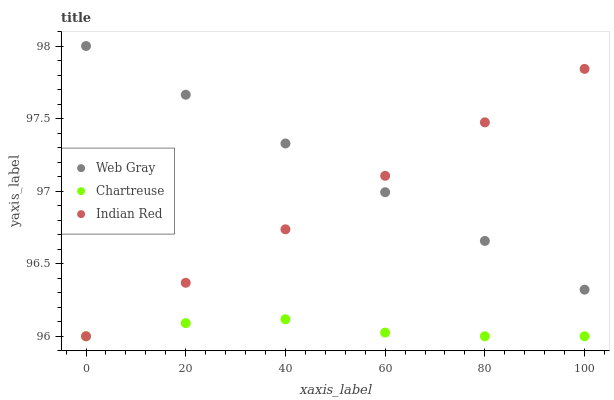Does Chartreuse have the minimum area under the curve?
Answer yes or no. Yes. Does Web Gray have the maximum area under the curve?
Answer yes or no. Yes. Does Indian Red have the minimum area under the curve?
Answer yes or no. No. Does Indian Red have the maximum area under the curve?
Answer yes or no. No. Is Web Gray the smoothest?
Answer yes or no. Yes. Is Chartreuse the roughest?
Answer yes or no. Yes. Is Indian Red the roughest?
Answer yes or no. No. Does Chartreuse have the lowest value?
Answer yes or no. Yes. Does Web Gray have the lowest value?
Answer yes or no. No. Does Web Gray have the highest value?
Answer yes or no. Yes. Does Indian Red have the highest value?
Answer yes or no. No. Is Chartreuse less than Web Gray?
Answer yes or no. Yes. Is Web Gray greater than Chartreuse?
Answer yes or no. Yes. Does Indian Red intersect Web Gray?
Answer yes or no. Yes. Is Indian Red less than Web Gray?
Answer yes or no. No. Is Indian Red greater than Web Gray?
Answer yes or no. No. Does Chartreuse intersect Web Gray?
Answer yes or no. No. 